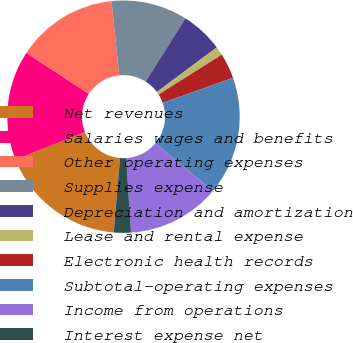Convert chart. <chart><loc_0><loc_0><loc_500><loc_500><pie_chart><fcel>Net revenues<fcel>Salaries wages and benefits<fcel>Other operating expenses<fcel>Supplies expense<fcel>Depreciation and amortization<fcel>Lease and rental expense<fcel>Electronic health records<fcel>Subtotal-operating expenses<fcel>Income from operations<fcel>Interest expense net<nl><fcel>17.63%<fcel>15.28%<fcel>14.11%<fcel>10.59%<fcel>5.89%<fcel>1.2%<fcel>3.54%<fcel>16.46%<fcel>12.93%<fcel>2.37%<nl></chart> 